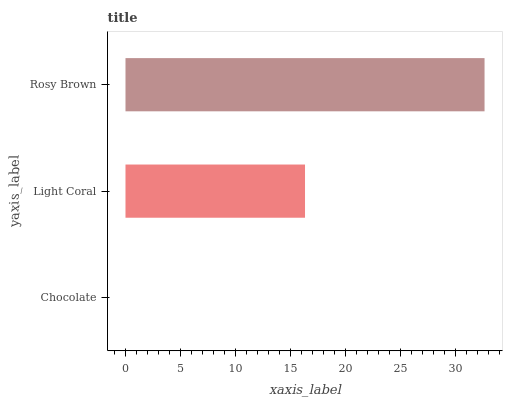Is Chocolate the minimum?
Answer yes or no. Yes. Is Rosy Brown the maximum?
Answer yes or no. Yes. Is Light Coral the minimum?
Answer yes or no. No. Is Light Coral the maximum?
Answer yes or no. No. Is Light Coral greater than Chocolate?
Answer yes or no. Yes. Is Chocolate less than Light Coral?
Answer yes or no. Yes. Is Chocolate greater than Light Coral?
Answer yes or no. No. Is Light Coral less than Chocolate?
Answer yes or no. No. Is Light Coral the high median?
Answer yes or no. Yes. Is Light Coral the low median?
Answer yes or no. Yes. Is Rosy Brown the high median?
Answer yes or no. No. Is Rosy Brown the low median?
Answer yes or no. No. 